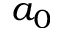Convert formula to latex. <formula><loc_0><loc_0><loc_500><loc_500>a _ { 0 }</formula> 